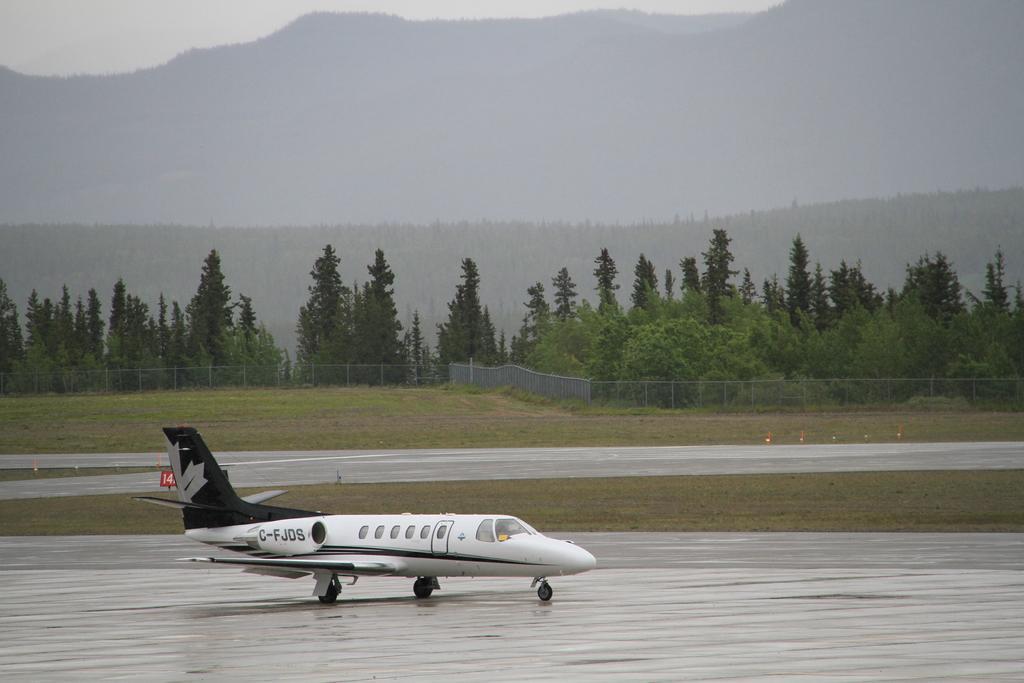Can you describe this image briefly? There is an aeroplane on the road. This is grass. Here we can see a fence, trees, mountain, and sky. 